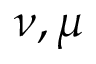Convert formula to latex. <formula><loc_0><loc_0><loc_500><loc_500>\nu , \mu</formula> 